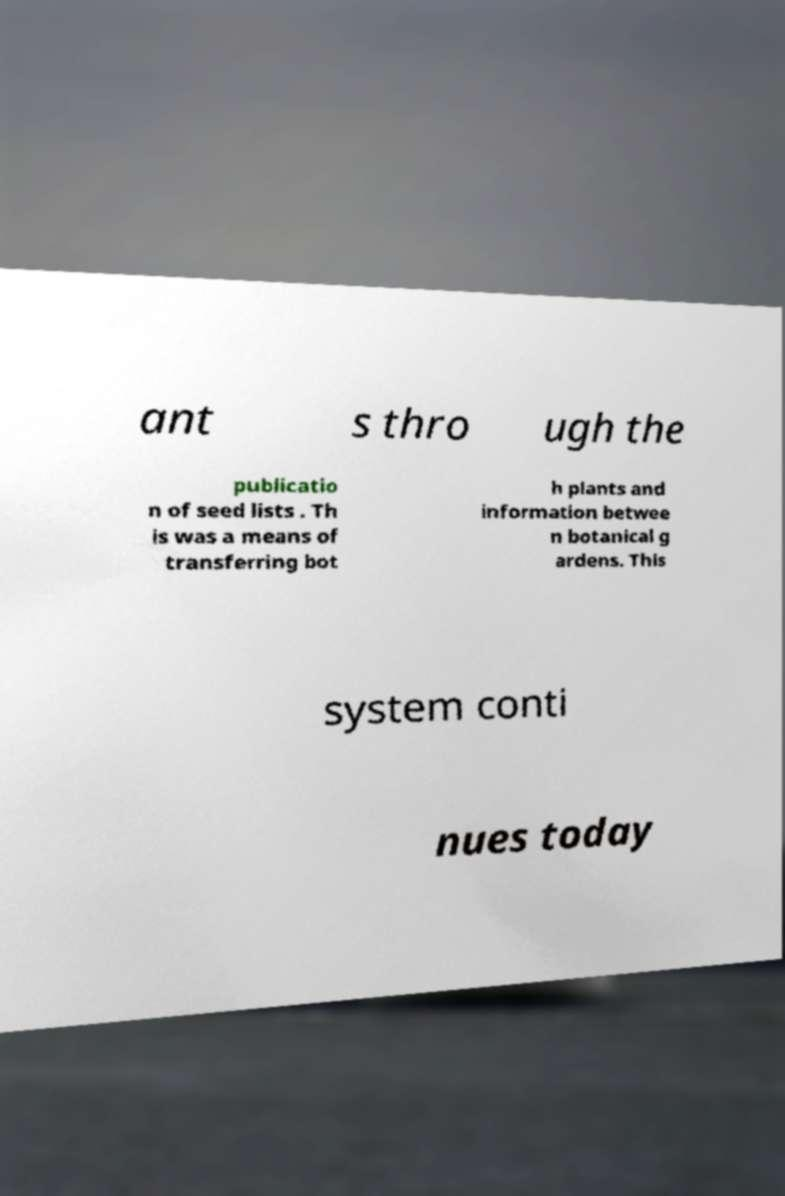For documentation purposes, I need the text within this image transcribed. Could you provide that? ant s thro ugh the publicatio n of seed lists . Th is was a means of transferring bot h plants and information betwee n botanical g ardens. This system conti nues today 